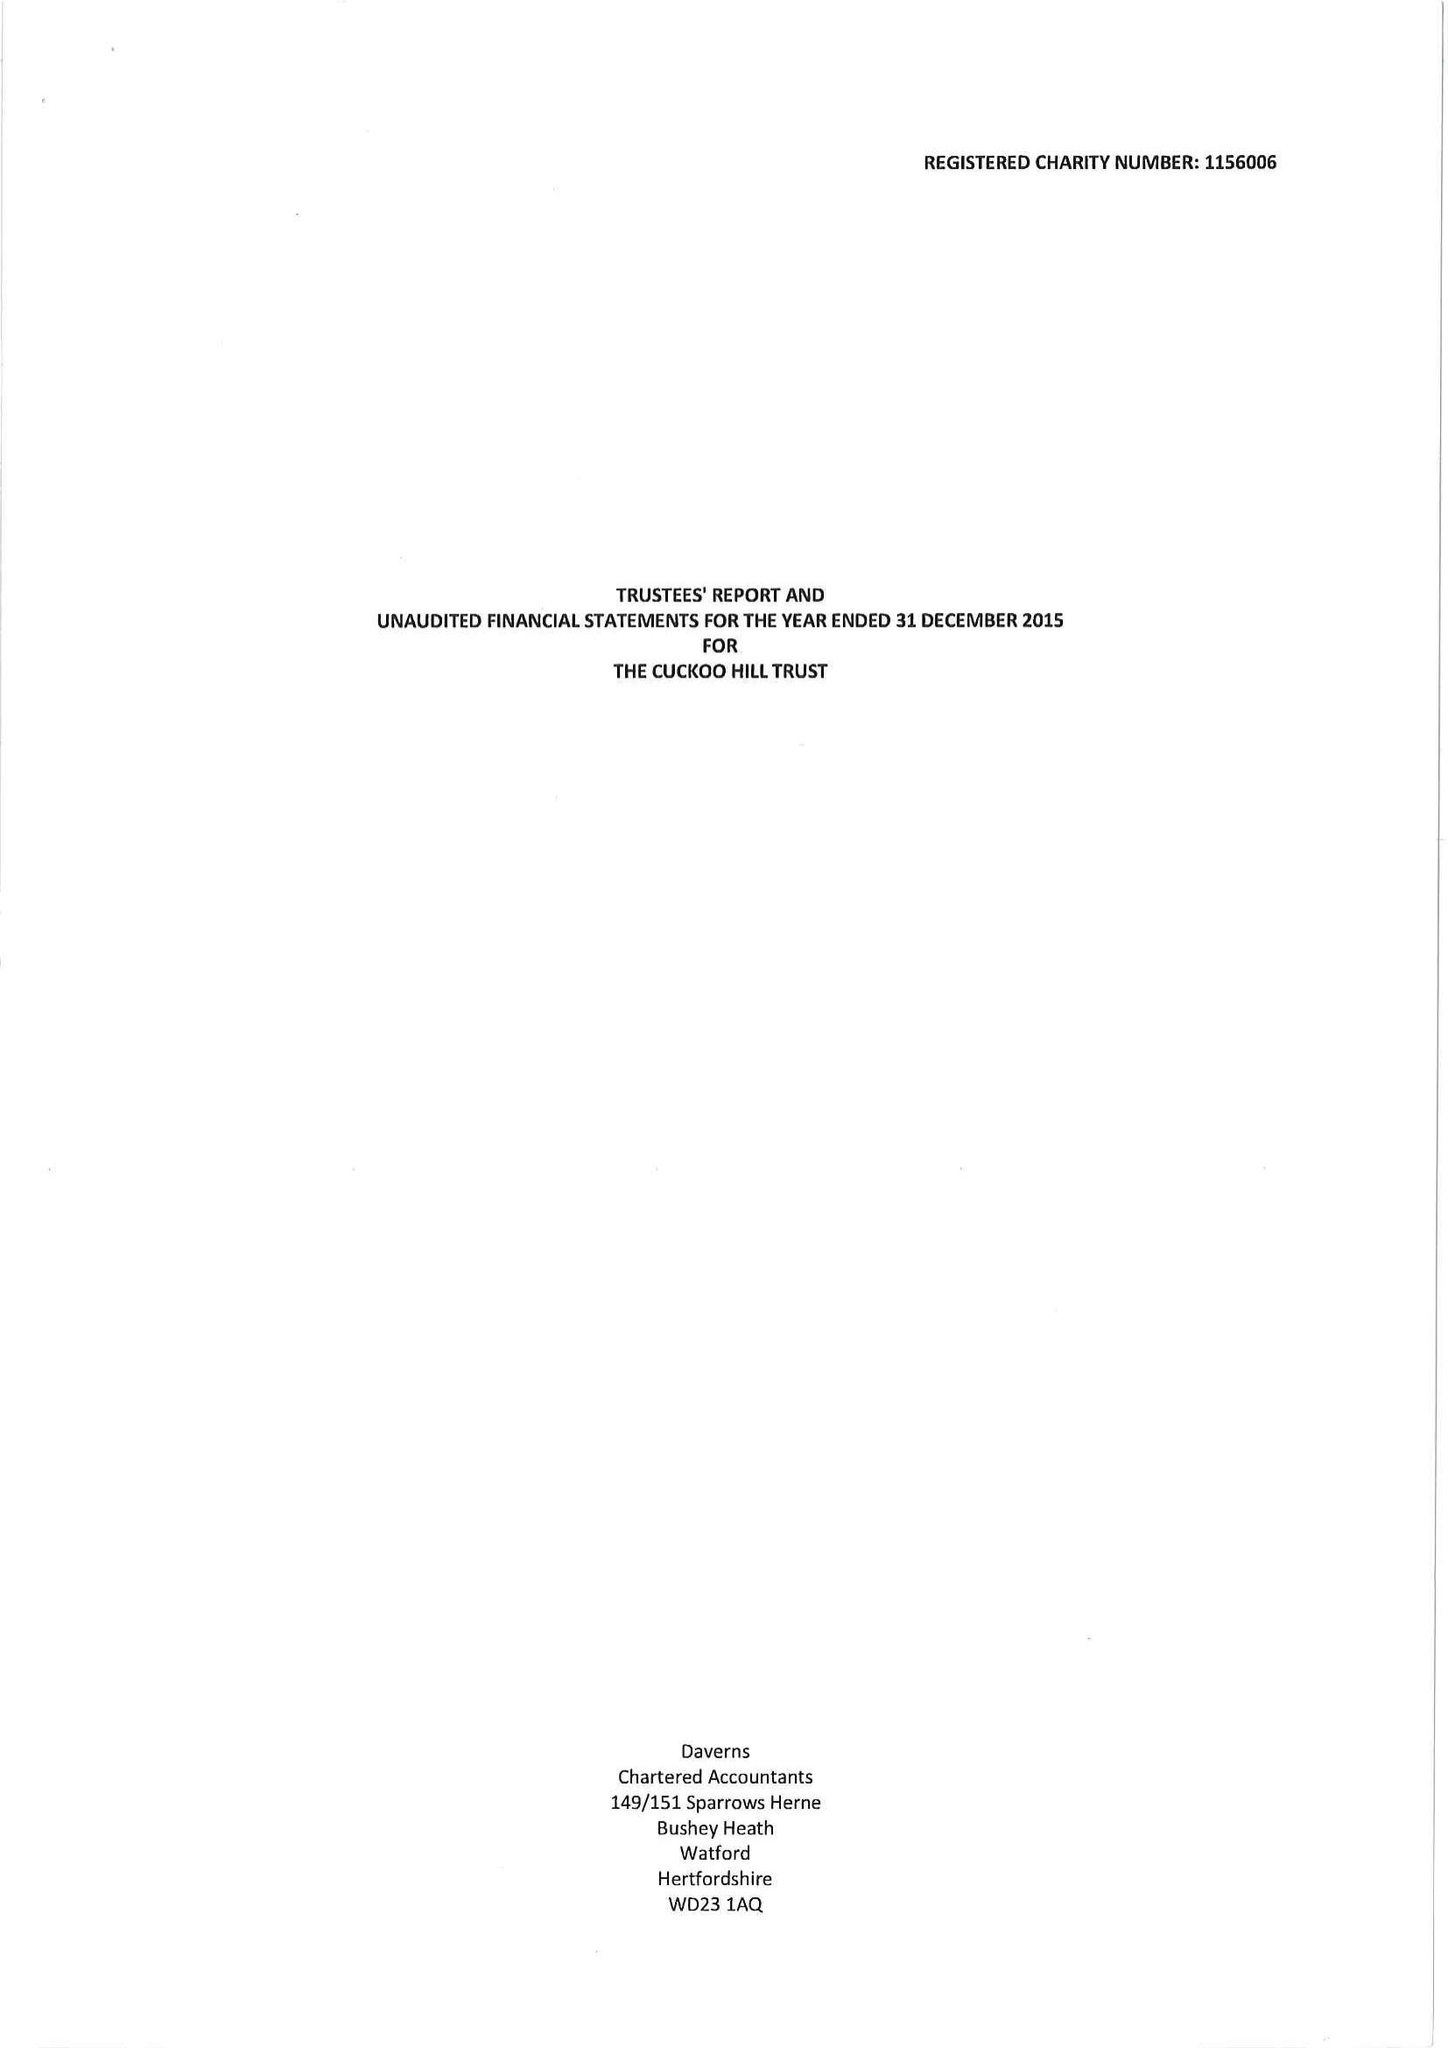What is the value for the address__post_town?
Answer the question using a single word or phrase. PINNER 